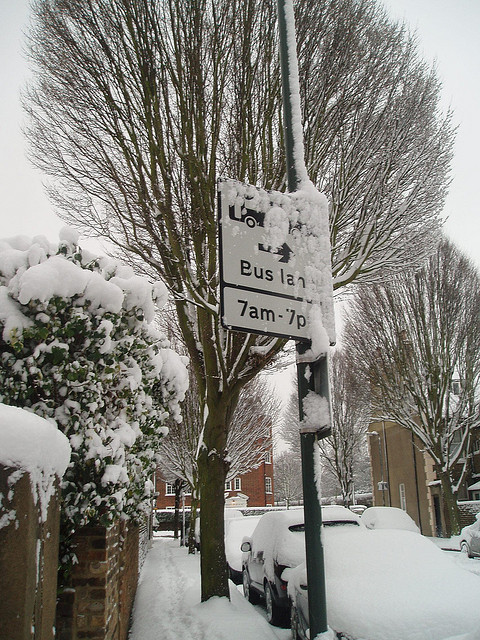Please transcribe the text in this image. Bus 7am 7p Ian 